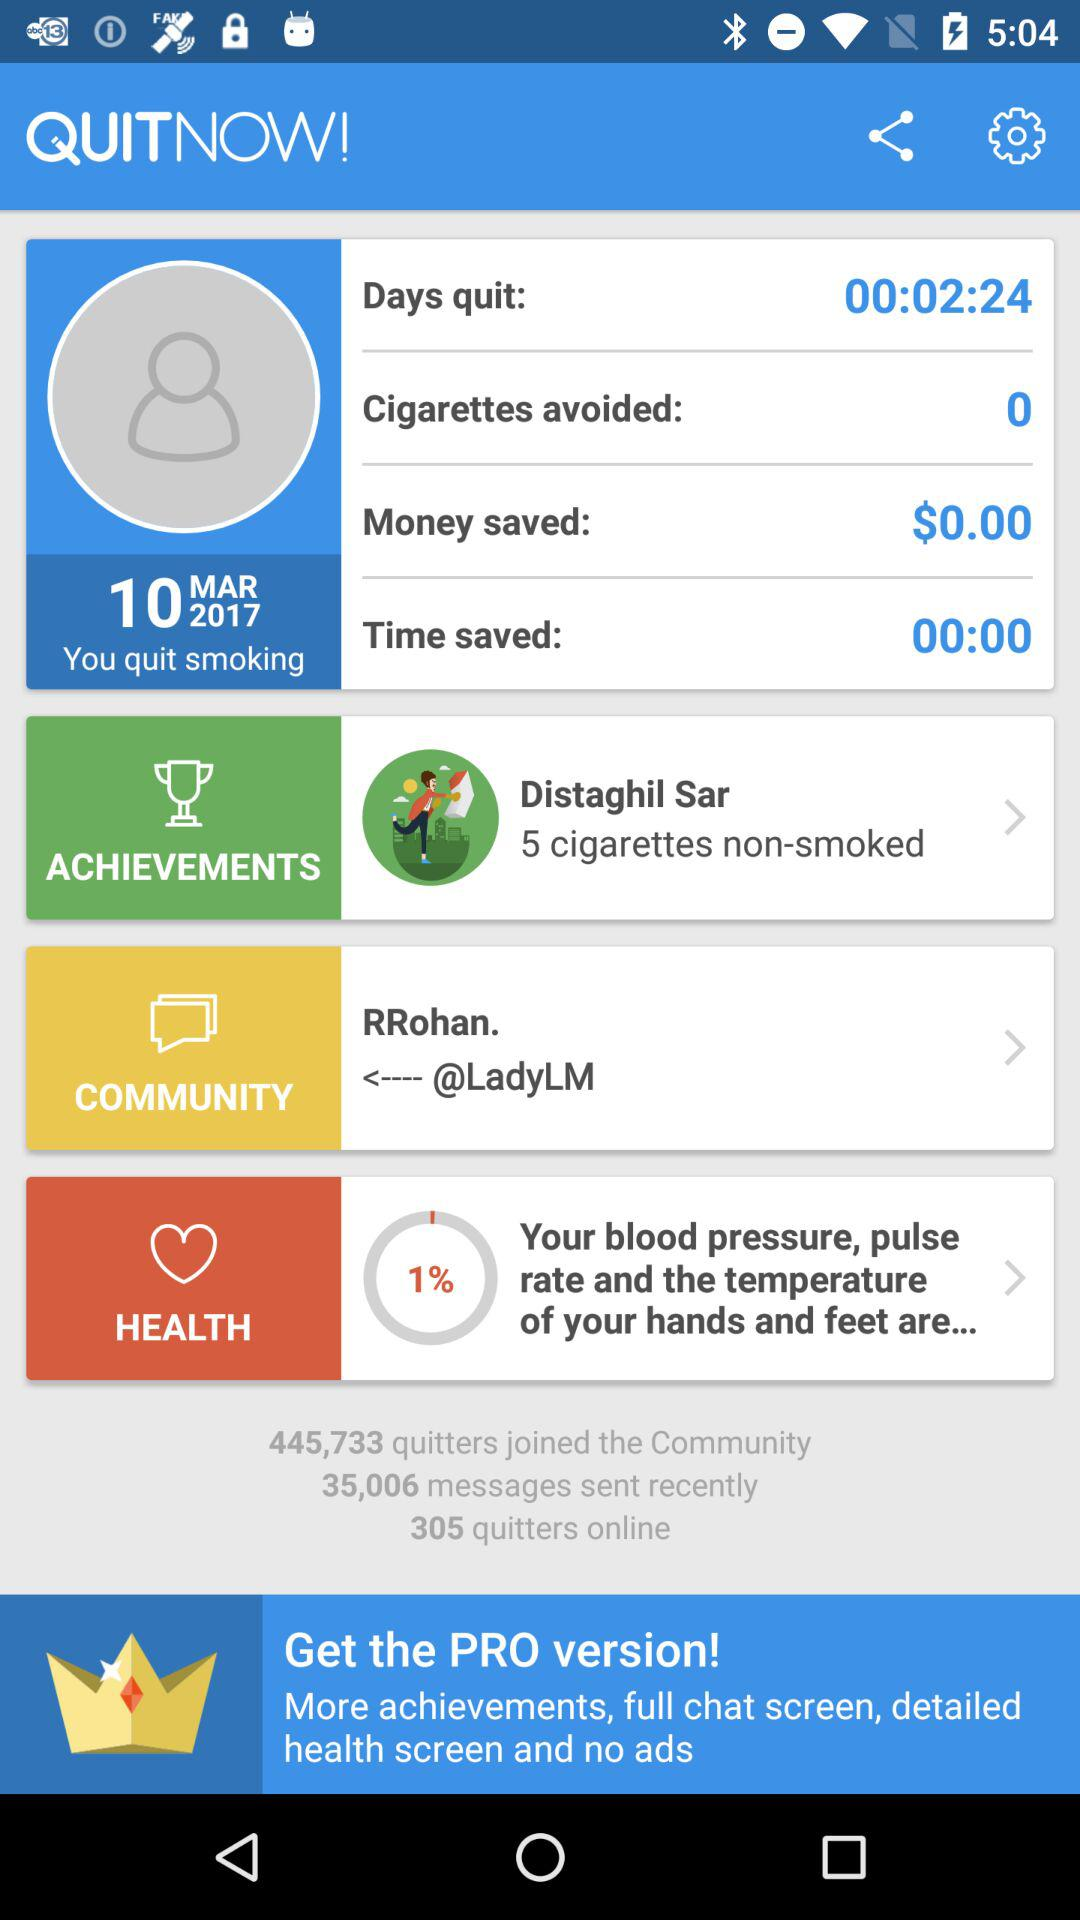How many quitters are online?
Answer the question using a single word or phrase. 305 